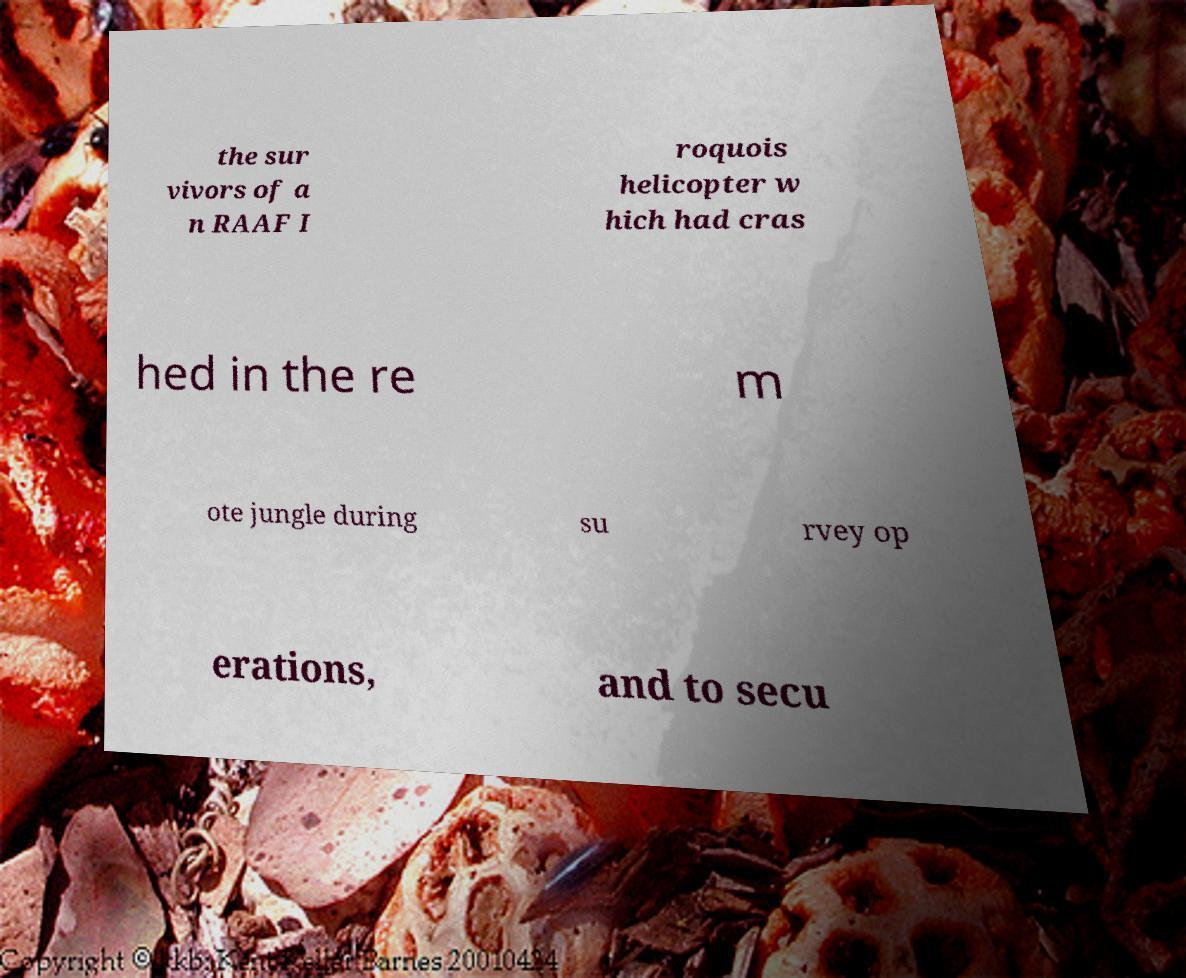Could you assist in decoding the text presented in this image and type it out clearly? the sur vivors of a n RAAF I roquois helicopter w hich had cras hed in the re m ote jungle during su rvey op erations, and to secu 